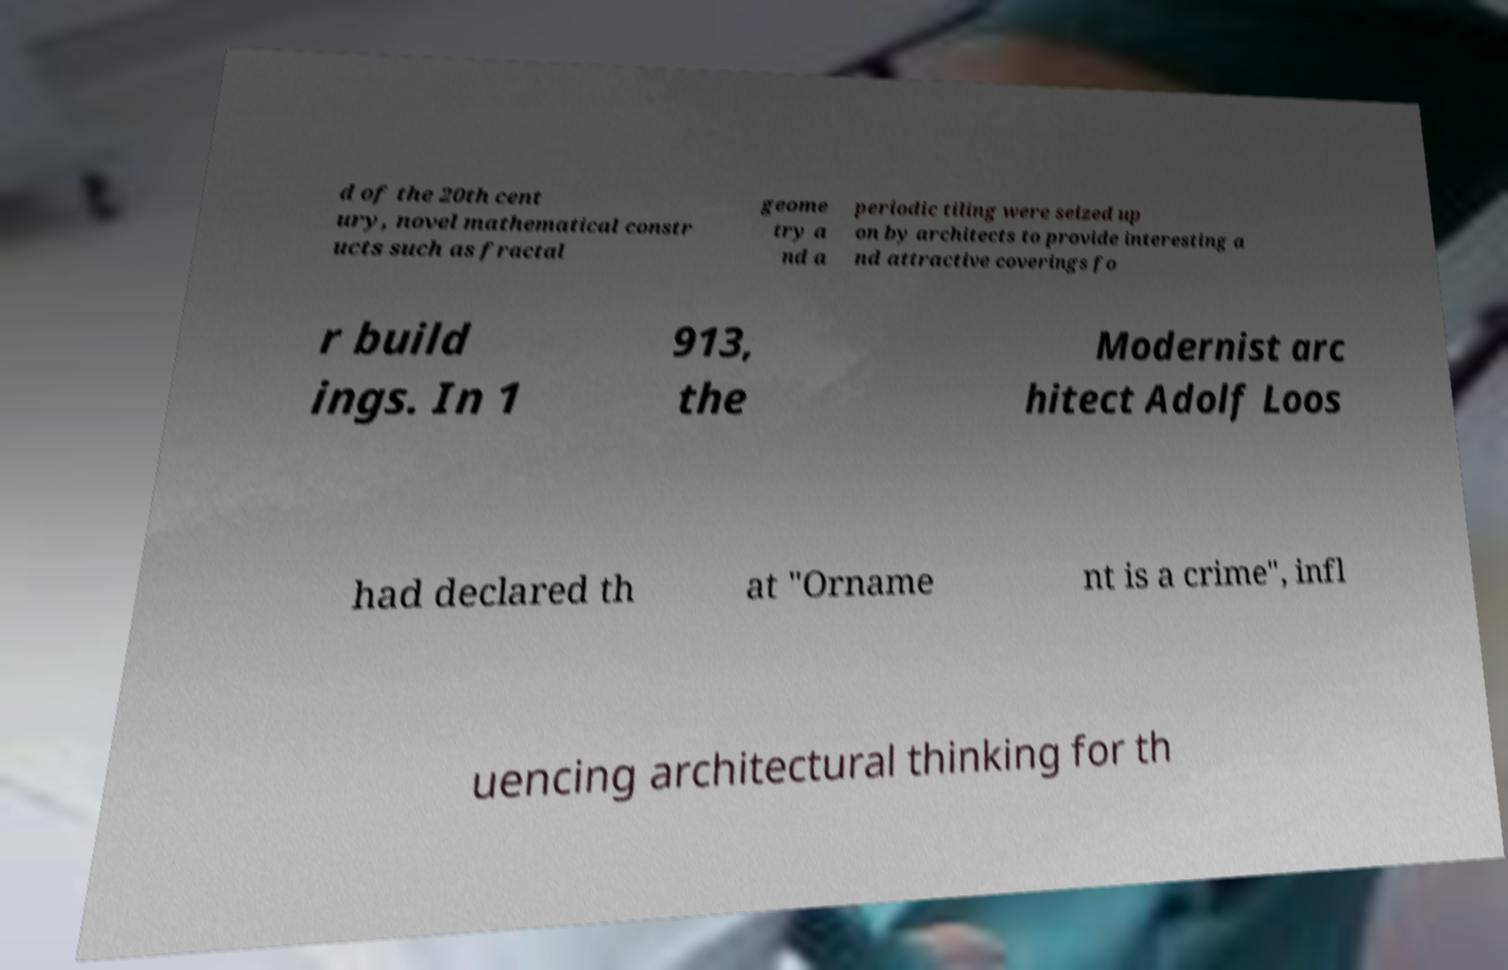I need the written content from this picture converted into text. Can you do that? d of the 20th cent ury, novel mathematical constr ucts such as fractal geome try a nd a periodic tiling were seized up on by architects to provide interesting a nd attractive coverings fo r build ings. In 1 913, the Modernist arc hitect Adolf Loos had declared th at "Orname nt is a crime", infl uencing architectural thinking for th 